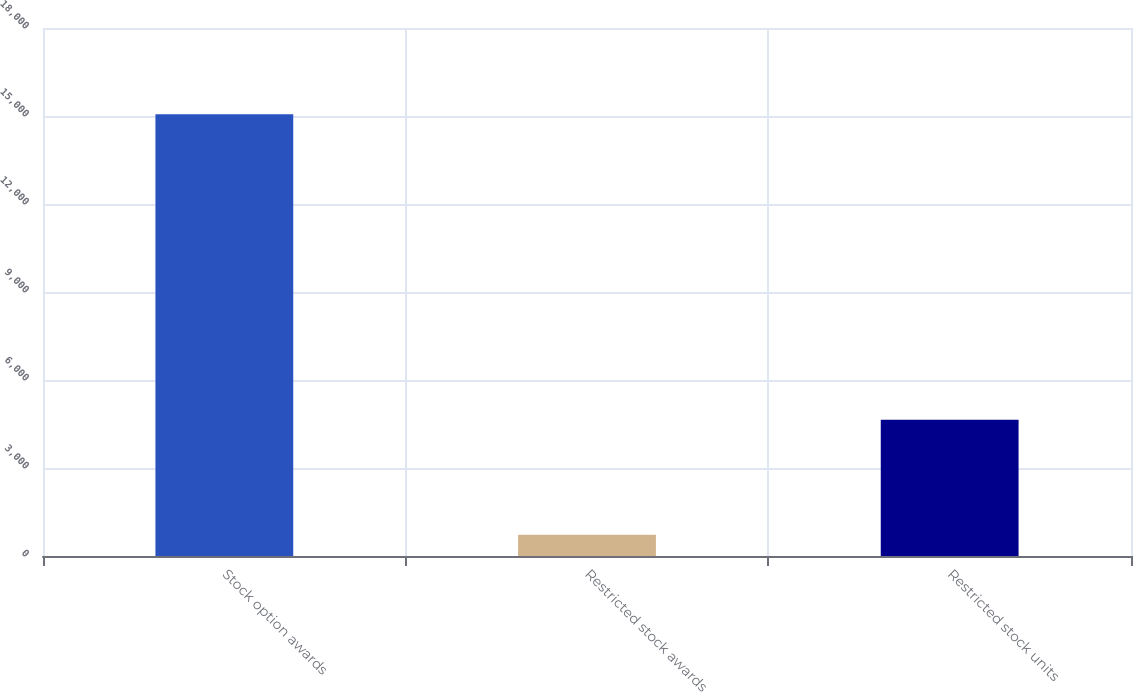Convert chart. <chart><loc_0><loc_0><loc_500><loc_500><bar_chart><fcel>Stock option awards<fcel>Restricted stock awards<fcel>Restricted stock units<nl><fcel>15063<fcel>728<fcel>4647<nl></chart> 